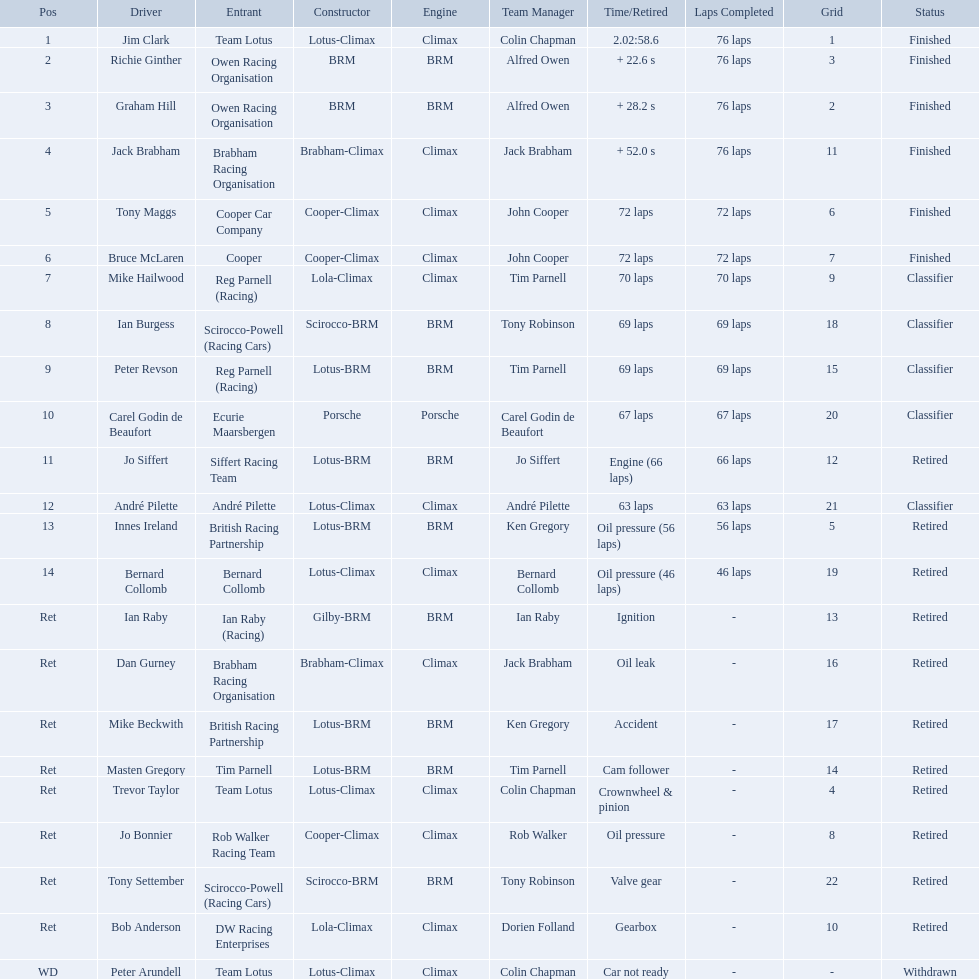Who are all the drivers? Jim Clark, Richie Ginther, Graham Hill, Jack Brabham, Tony Maggs, Bruce McLaren, Mike Hailwood, Ian Burgess, Peter Revson, Carel Godin de Beaufort, Jo Siffert, André Pilette, Innes Ireland, Bernard Collomb, Ian Raby, Dan Gurney, Mike Beckwith, Masten Gregory, Trevor Taylor, Jo Bonnier, Tony Settember, Bob Anderson, Peter Arundell. What position were they in? 1, 2, 3, 4, 5, 6, 7, 8, 9, 10, 11, 12, 13, 14, Ret, Ret, Ret, Ret, Ret, Ret, Ret, Ret, WD. What about just tony maggs and jo siffert? 5, 11. And between them, which driver came in earlier? Tony Maggs. Who were the drivers at the 1963 international gold cup? Jim Clark, Richie Ginther, Graham Hill, Jack Brabham, Tony Maggs, Bruce McLaren, Mike Hailwood, Ian Burgess, Peter Revson, Carel Godin de Beaufort, Jo Siffert, André Pilette, Innes Ireland, Bernard Collomb, Ian Raby, Dan Gurney, Mike Beckwith, Masten Gregory, Trevor Taylor, Jo Bonnier, Tony Settember, Bob Anderson, Peter Arundell. What was tony maggs position? 5. What was jo siffert? 11. Who came in earlier? Tony Maggs. Who are all the drivers? Jim Clark, Richie Ginther, Graham Hill, Jack Brabham, Tony Maggs, Bruce McLaren, Mike Hailwood, Ian Burgess, Peter Revson, Carel Godin de Beaufort, Jo Siffert, André Pilette, Innes Ireland, Bernard Collomb, Ian Raby, Dan Gurney, Mike Beckwith, Masten Gregory, Trevor Taylor, Jo Bonnier, Tony Settember, Bob Anderson, Peter Arundell. What were their positions? 1, 2, 3, 4, 5, 6, 7, 8, 9, 10, 11, 12, 13, 14, Ret, Ret, Ret, Ret, Ret, Ret, Ret, Ret, WD. What are all the constructor names? Lotus-Climax, BRM, BRM, Brabham-Climax, Cooper-Climax, Cooper-Climax, Lola-Climax, Scirocco-BRM, Lotus-BRM, Porsche, Lotus-BRM, Lotus-Climax, Lotus-BRM, Lotus-Climax, Gilby-BRM, Brabham-Climax, Lotus-BRM, Lotus-BRM, Lotus-Climax, Cooper-Climax, Scirocco-BRM, Lola-Climax, Lotus-Climax. And which drivers drove a cooper-climax? Tony Maggs, Bruce McLaren. Between those tow, who was positioned higher? Tony Maggs. Who are all the drivers? Jim Clark, Richie Ginther, Graham Hill, Jack Brabham, Tony Maggs, Bruce McLaren, Mike Hailwood, Ian Burgess, Peter Revson, Carel Godin de Beaufort, Jo Siffert, André Pilette, Innes Ireland, Bernard Collomb, Ian Raby, Dan Gurney, Mike Beckwith, Masten Gregory, Trevor Taylor, Jo Bonnier, Tony Settember, Bob Anderson, Peter Arundell. Which drove a cooper-climax? Tony Maggs, Bruce McLaren, Jo Bonnier. Of those, who was the top finisher? Tony Maggs. Who were the drivers in the the 1963 international gold cup? Jim Clark, Richie Ginther, Graham Hill, Jack Brabham, Tony Maggs, Bruce McLaren, Mike Hailwood, Ian Burgess, Peter Revson, Carel Godin de Beaufort, Jo Siffert, André Pilette, Innes Ireland, Bernard Collomb, Ian Raby, Dan Gurney, Mike Beckwith, Masten Gregory, Trevor Taylor, Jo Bonnier, Tony Settember, Bob Anderson, Peter Arundell. Which drivers drove a cooper-climax car? Tony Maggs, Bruce McLaren, Jo Bonnier. What did these drivers place? 5, 6, Ret. What was the best placing position? 5. Who was the driver with this placing? Tony Maggs. Who all drive cars that were constructed bur climax? Jim Clark, Jack Brabham, Tony Maggs, Bruce McLaren, Mike Hailwood, André Pilette, Bernard Collomb, Dan Gurney, Trevor Taylor, Jo Bonnier, Bob Anderson, Peter Arundell. Which driver's climax constructed cars started in the top 10 on the grid? Jim Clark, Tony Maggs, Bruce McLaren, Mike Hailwood, Jo Bonnier, Bob Anderson. Of the top 10 starting climax constructed drivers, which ones did not finish the race? Jo Bonnier, Bob Anderson. What was the failure that was engine related that took out the driver of the climax constructed car that did not finish even though it started in the top 10? Oil pressure. Who were the two that that a similar problem? Innes Ireland. What was their common problem? Oil pressure. 